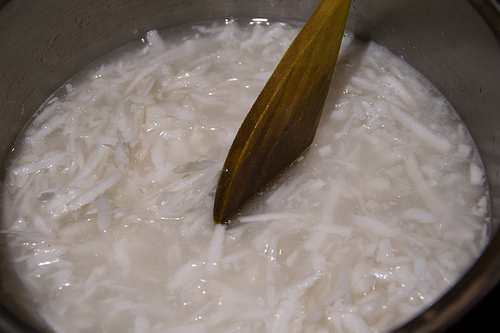<image>
Is the spoon behind the soup? No. The spoon is not behind the soup. From this viewpoint, the spoon appears to be positioned elsewhere in the scene. Is there a spoon in the soup? Yes. The spoon is contained within or inside the soup, showing a containment relationship. 